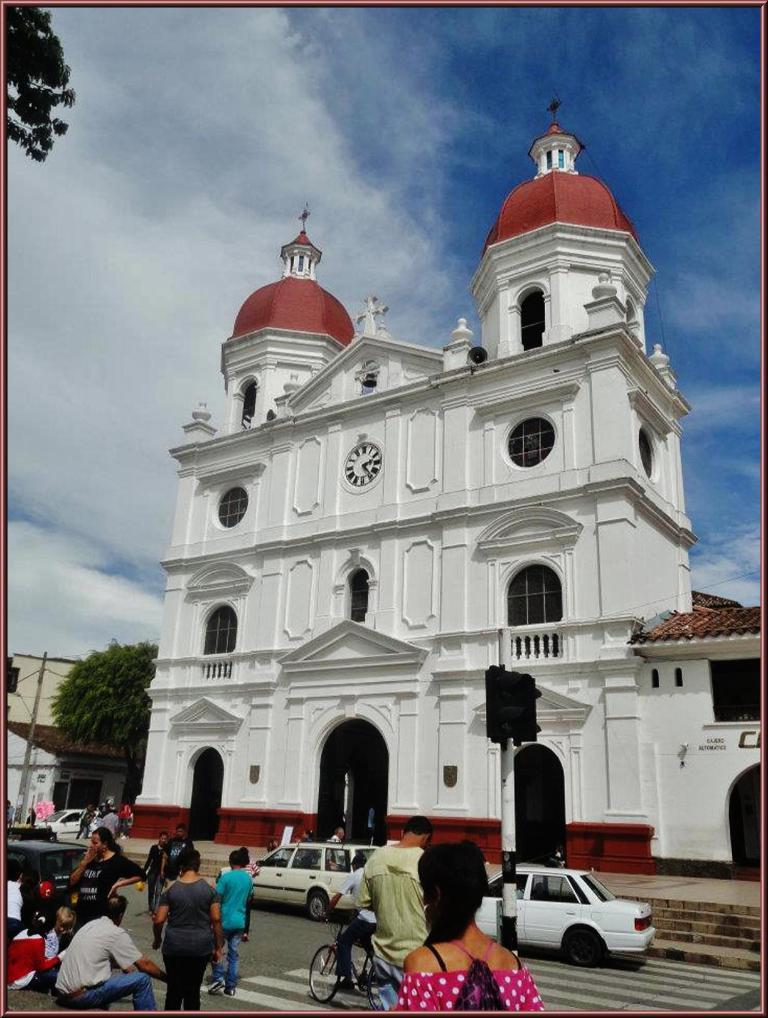How many people are in the image? There is a group of people in the image. What else can be seen in the image besides the people? There are buildings, trees, vehicles, and poles in the image. What is visible in the background of the image? The sky is visible in the background of the image. What is the father doing with his leg in the image? There is no father or leg present in the image. 